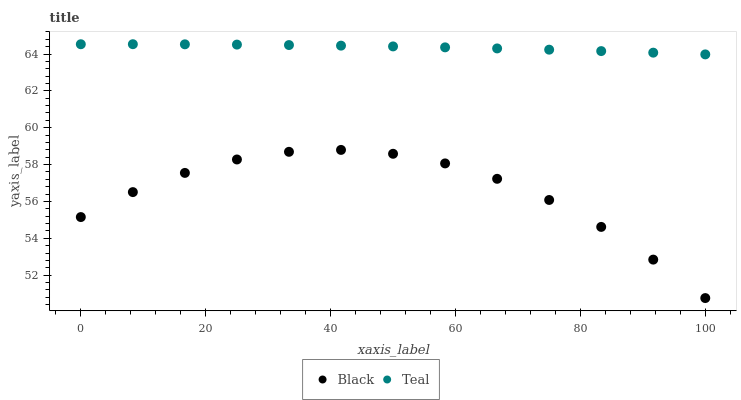Does Black have the minimum area under the curve?
Answer yes or no. Yes. Does Teal have the maximum area under the curve?
Answer yes or no. Yes. Does Teal have the minimum area under the curve?
Answer yes or no. No. Is Teal the smoothest?
Answer yes or no. Yes. Is Black the roughest?
Answer yes or no. Yes. Is Teal the roughest?
Answer yes or no. No. Does Black have the lowest value?
Answer yes or no. Yes. Does Teal have the lowest value?
Answer yes or no. No. Does Teal have the highest value?
Answer yes or no. Yes. Is Black less than Teal?
Answer yes or no. Yes. Is Teal greater than Black?
Answer yes or no. Yes. Does Black intersect Teal?
Answer yes or no. No. 